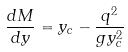Convert formula to latex. <formula><loc_0><loc_0><loc_500><loc_500>\frac { d M } { d y } = y _ { c } - \frac { q ^ { 2 } } { g y _ { c } ^ { 2 } }</formula> 